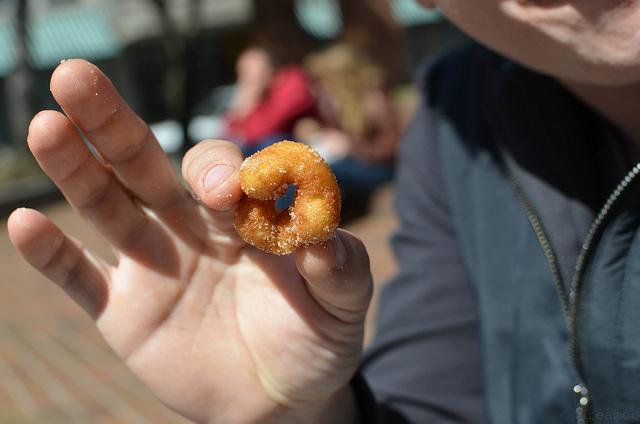How many fingers are pointing upward?
Be succinct. 3. Is the banana he's holding eaten or uneaten?
Give a very brief answer. Uneaten. Where did he get the onion ring?
Concise answer only. Restaurant. What color is the person's jacket?
Short answer required. Black. Is this a plain doughnut?
Keep it brief. Yes. What is the hand holding?
Write a very short answer. Donut. What color is the man's shirt?
Quick response, please. Blue. 